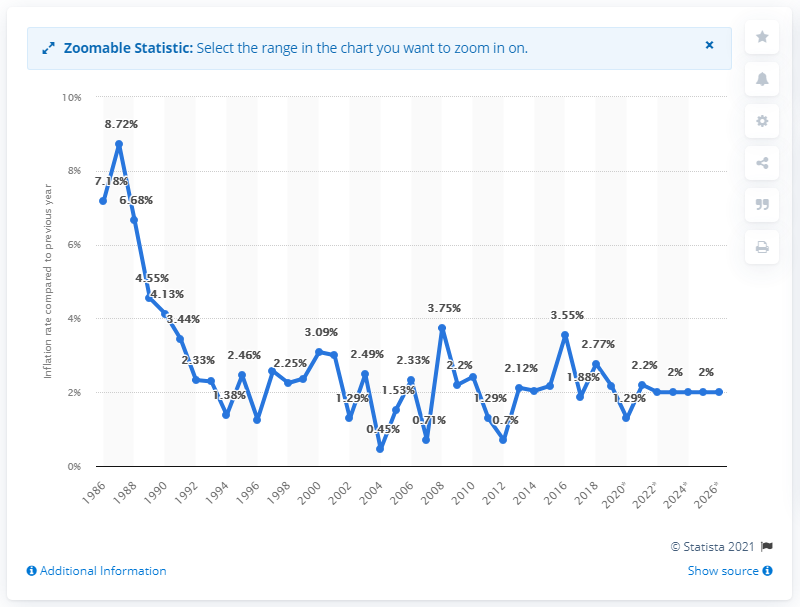Point out several critical features in this image. In 1986, the average inflation rate in Norway was. 